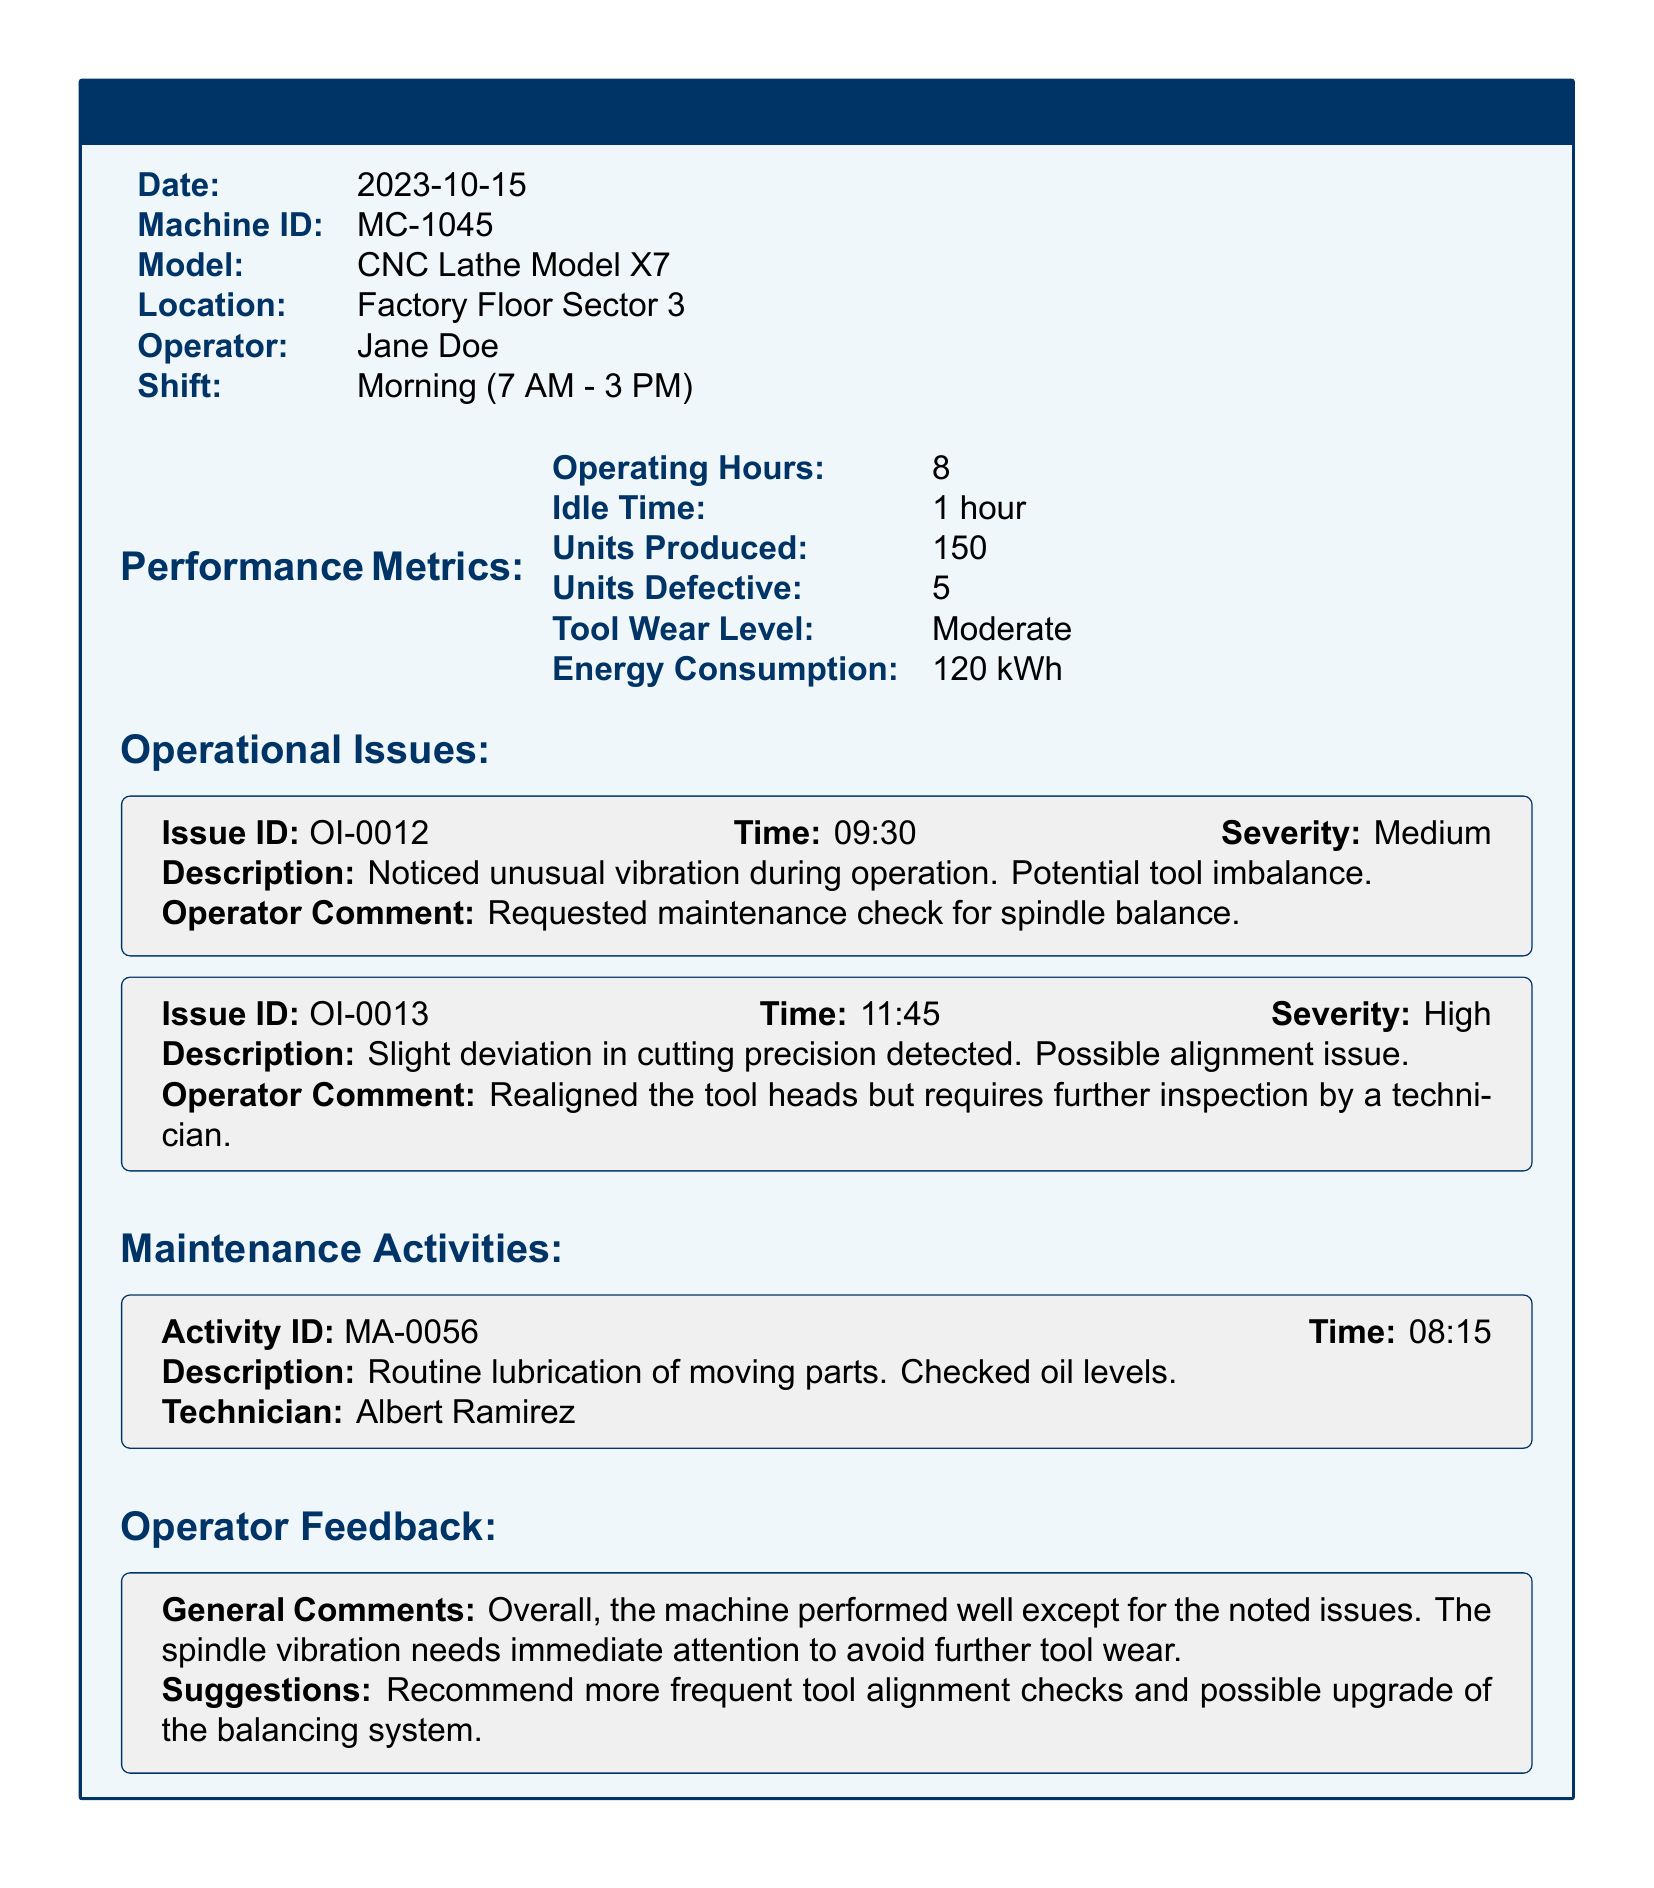What is the date of the report? The date is found in the header section of the document.
Answer: 2023-10-15 Who is the operator of the machine? The operator's name is specified in the header section.
Answer: Jane Doe What was the idle time recorded? The idle time is listed under Performance Metrics.
Answer: 1 hour How many units were produced during the shift? This information is stated in the Performance Metrics section.
Answer: 150 What is the severity of the first operational issue? The severity level is indicated in the Operational Issues section for the first issue.
Answer: Medium What actions did the operator take regarding the cutting precision issue? Operator actions are detailed in the operator comments related to the second issue.
Answer: Realigned the tool heads What maintenance activity was performed? The maintenance activity can be found in the Maintenance Activities section.
Answer: Routine lubrication of moving parts What is the general feedback from the operator? General comments are located in the Operator Feedback section.
Answer: Overall, the machine performed well except for the noted issues What is the recommendation given by the operator? The operator's suggestions are found in the Operator Feedback section.
Answer: Recommend more frequent tool alignment checks 